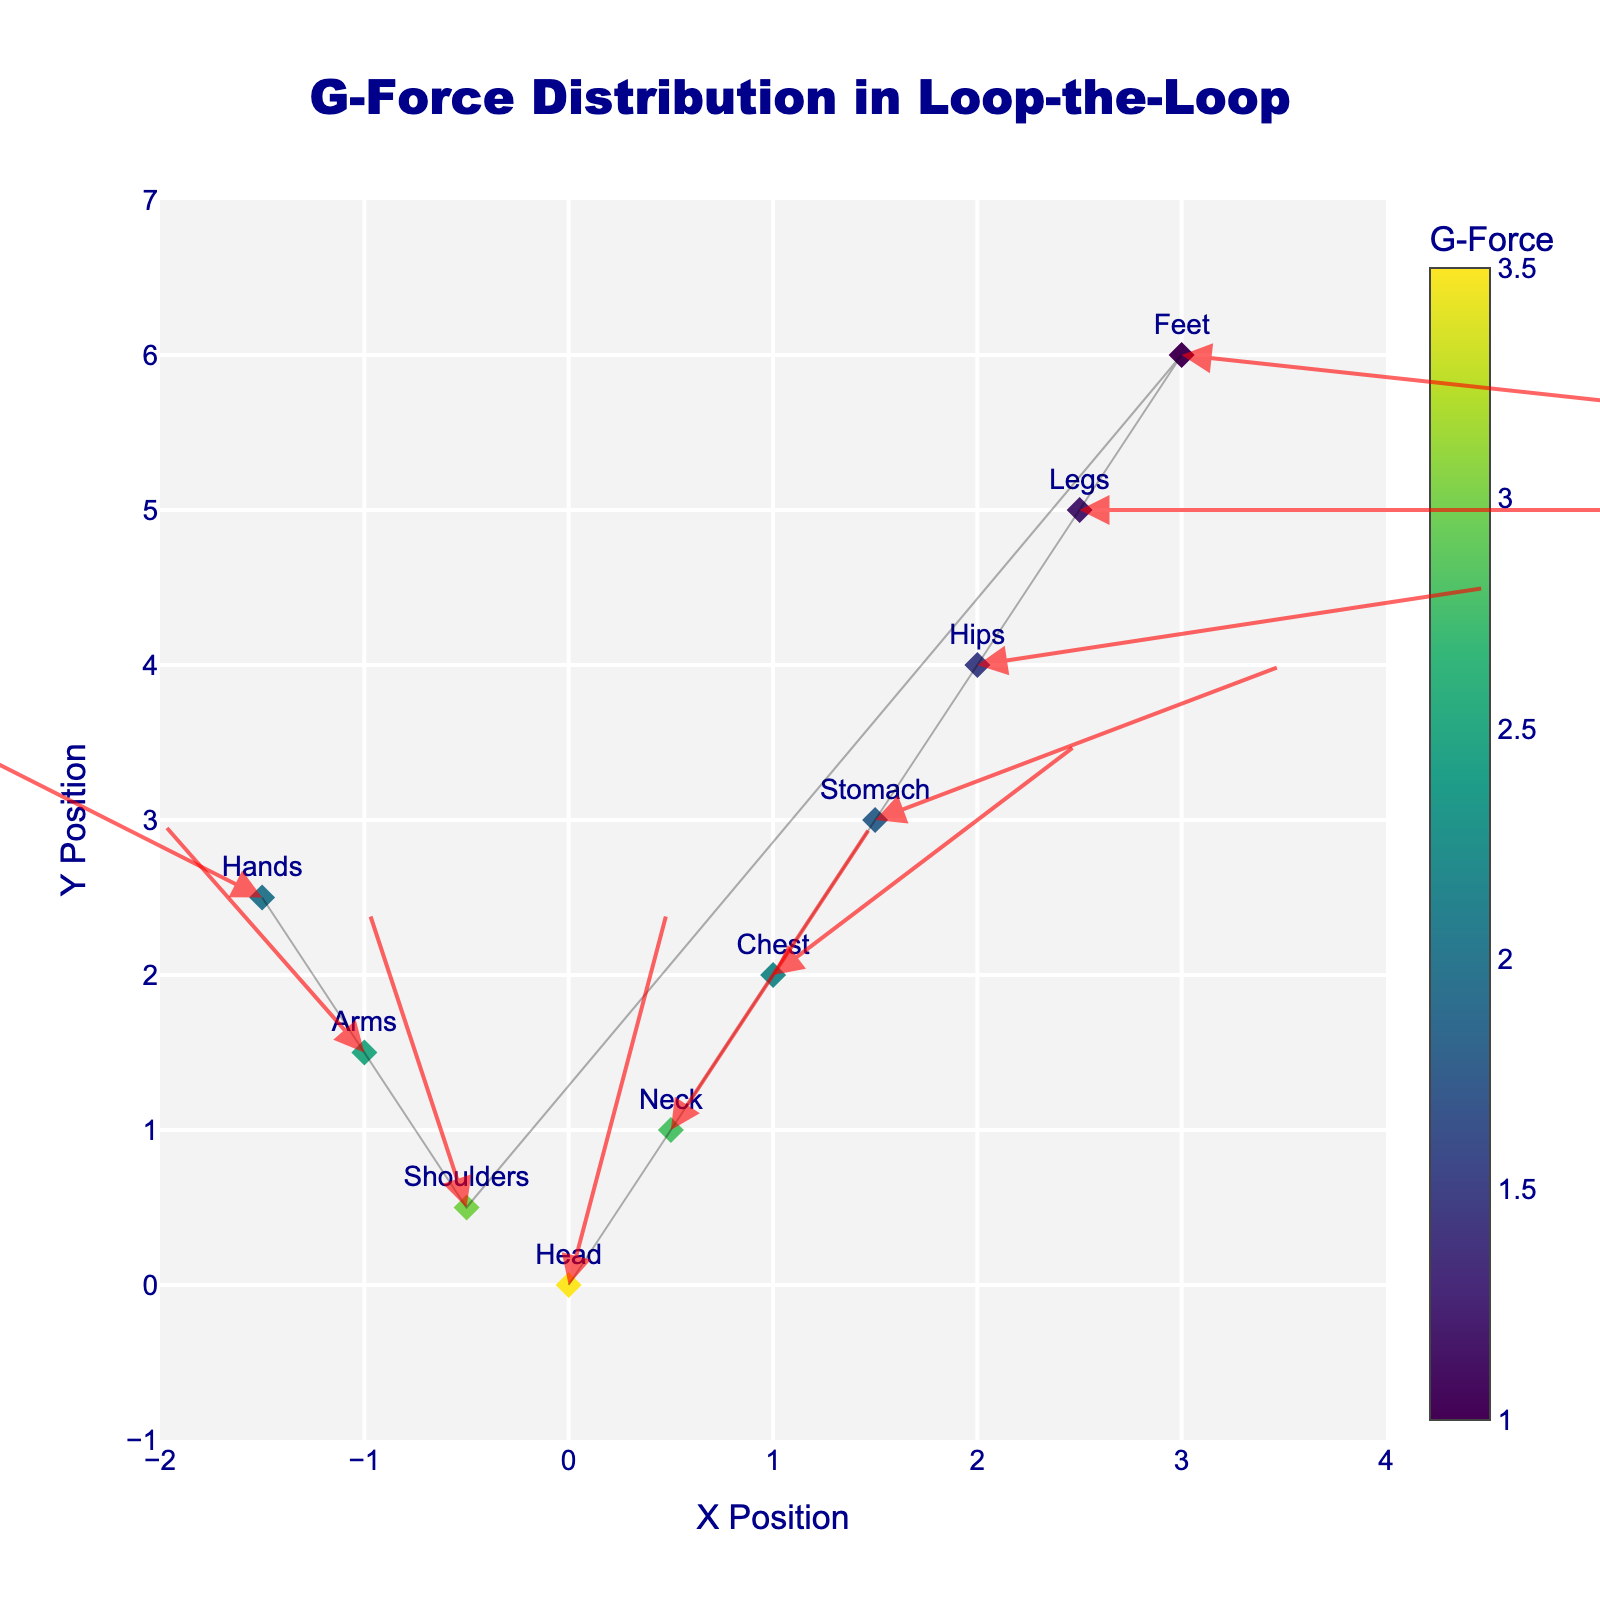What is the highest G-Force and which body part experiences it? Look at the color scale and the hover information, the highest G-Force is 3.5 experienced by the "Head".
Answer: 3.5, Head Which body part experiences the lowest G-Force? Check the color scale and hover information, the lowest G-Force is 1.0, experienced by the "Feet".
Answer: Feet Which direction does the force vector on the "Shoulders" point? Observe the arrow starting at the "Shoulders" coordinates (-0.5,0.5) pointing upwards with a slight switch to the right.
Answer: Up-right What is the average G-Force for the top three body parts in terms of G-Force? The top three body parts by G-Force are "Head" (3.5), "Shoulders" (3.0), and "Neck" (2.8). Sum these values (3.5 + 3.0 + 2.8 = 9.3) then divide by 3, the average is 3.1.
Answer: 3.1 Compare the G-Force experienced by the "Legs" and "Arms". Which is greater? From the hover information, Legs experience 1.2 Gs and Arms experience 2.5 Gs.
Answer: Arms How many data points are displayed in the figure? Count each unique position from the visual markers. There are 10 data points.
Answer: 10 What are the x and y range values displayed in the figure? The figure's axes range from -2 to 4 on the x-axis and -1 to 7 on the y-axis.
Answer: x: -2 to 4, y: -1 to 7 Which body part’s force vector points closest to the x-axis? The "Legs" vector points almost horizontally along the x-axis, as its vertical component is zero.
Answer: Legs What body part is located at coordinates (0.5, 1)? Looking at the point with coordinates (0.5, 1), this is labeled as "Neck".
Answer: Neck 